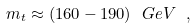<formula> <loc_0><loc_0><loc_500><loc_500>m _ { t } \approx ( 1 6 0 - 1 9 0 ) \ G e V \ ,</formula> 